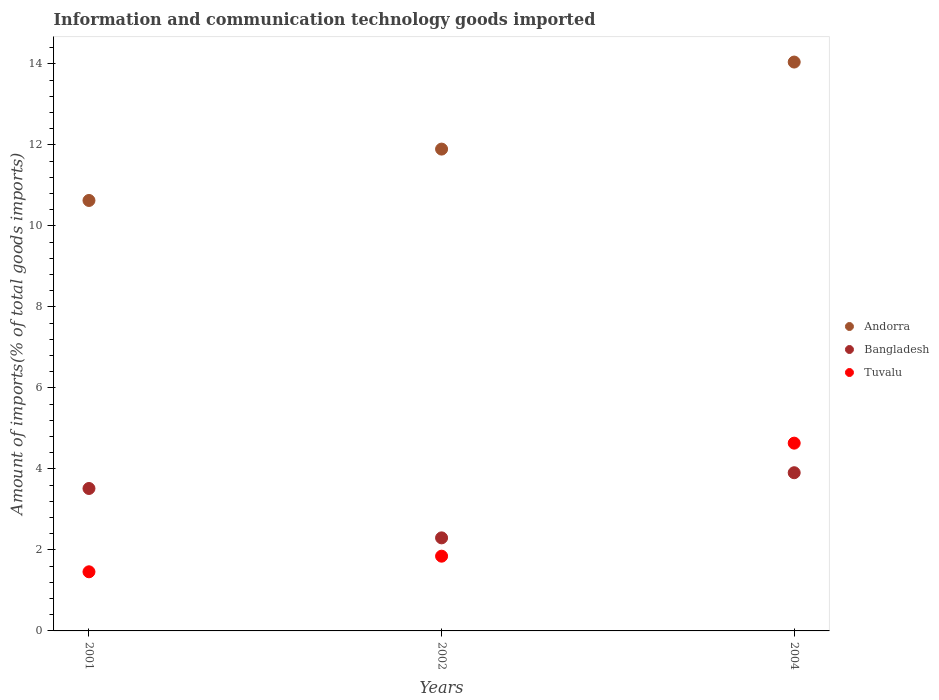How many different coloured dotlines are there?
Give a very brief answer. 3. What is the amount of goods imported in Tuvalu in 2004?
Offer a very short reply. 4.64. Across all years, what is the maximum amount of goods imported in Andorra?
Keep it short and to the point. 14.05. Across all years, what is the minimum amount of goods imported in Bangladesh?
Keep it short and to the point. 2.3. What is the total amount of goods imported in Tuvalu in the graph?
Provide a succinct answer. 7.94. What is the difference between the amount of goods imported in Tuvalu in 2002 and that in 2004?
Your answer should be compact. -2.79. What is the difference between the amount of goods imported in Tuvalu in 2004 and the amount of goods imported in Andorra in 2002?
Give a very brief answer. -7.26. What is the average amount of goods imported in Tuvalu per year?
Provide a short and direct response. 2.65. In the year 2001, what is the difference between the amount of goods imported in Tuvalu and amount of goods imported in Andorra?
Keep it short and to the point. -9.17. In how many years, is the amount of goods imported in Tuvalu greater than 8.4 %?
Give a very brief answer. 0. What is the ratio of the amount of goods imported in Bangladesh in 2001 to that in 2002?
Provide a succinct answer. 1.53. Is the amount of goods imported in Tuvalu in 2001 less than that in 2002?
Offer a terse response. Yes. Is the difference between the amount of goods imported in Tuvalu in 2001 and 2002 greater than the difference between the amount of goods imported in Andorra in 2001 and 2002?
Offer a terse response. Yes. What is the difference between the highest and the second highest amount of goods imported in Andorra?
Offer a terse response. 2.15. What is the difference between the highest and the lowest amount of goods imported in Bangladesh?
Ensure brevity in your answer.  1.61. Is the sum of the amount of goods imported in Tuvalu in 2001 and 2004 greater than the maximum amount of goods imported in Bangladesh across all years?
Keep it short and to the point. Yes. Is it the case that in every year, the sum of the amount of goods imported in Andorra and amount of goods imported in Tuvalu  is greater than the amount of goods imported in Bangladesh?
Your answer should be very brief. Yes. How many dotlines are there?
Keep it short and to the point. 3. How many years are there in the graph?
Make the answer very short. 3. Are the values on the major ticks of Y-axis written in scientific E-notation?
Provide a succinct answer. No. Does the graph contain grids?
Your response must be concise. No. What is the title of the graph?
Ensure brevity in your answer.  Information and communication technology goods imported. Does "World" appear as one of the legend labels in the graph?
Your response must be concise. No. What is the label or title of the Y-axis?
Offer a very short reply. Amount of imports(% of total goods imports). What is the Amount of imports(% of total goods imports) of Andorra in 2001?
Ensure brevity in your answer.  10.63. What is the Amount of imports(% of total goods imports) of Bangladesh in 2001?
Your answer should be compact. 3.52. What is the Amount of imports(% of total goods imports) in Tuvalu in 2001?
Your answer should be compact. 1.46. What is the Amount of imports(% of total goods imports) in Andorra in 2002?
Offer a very short reply. 11.9. What is the Amount of imports(% of total goods imports) in Bangladesh in 2002?
Offer a very short reply. 2.3. What is the Amount of imports(% of total goods imports) in Tuvalu in 2002?
Your response must be concise. 1.85. What is the Amount of imports(% of total goods imports) of Andorra in 2004?
Your response must be concise. 14.05. What is the Amount of imports(% of total goods imports) in Bangladesh in 2004?
Keep it short and to the point. 3.91. What is the Amount of imports(% of total goods imports) of Tuvalu in 2004?
Make the answer very short. 4.64. Across all years, what is the maximum Amount of imports(% of total goods imports) of Andorra?
Keep it short and to the point. 14.05. Across all years, what is the maximum Amount of imports(% of total goods imports) of Bangladesh?
Your answer should be very brief. 3.91. Across all years, what is the maximum Amount of imports(% of total goods imports) in Tuvalu?
Give a very brief answer. 4.64. Across all years, what is the minimum Amount of imports(% of total goods imports) in Andorra?
Offer a very short reply. 10.63. Across all years, what is the minimum Amount of imports(% of total goods imports) in Bangladesh?
Make the answer very short. 2.3. Across all years, what is the minimum Amount of imports(% of total goods imports) in Tuvalu?
Ensure brevity in your answer.  1.46. What is the total Amount of imports(% of total goods imports) of Andorra in the graph?
Give a very brief answer. 36.57. What is the total Amount of imports(% of total goods imports) in Bangladesh in the graph?
Provide a short and direct response. 9.72. What is the total Amount of imports(% of total goods imports) in Tuvalu in the graph?
Provide a succinct answer. 7.94. What is the difference between the Amount of imports(% of total goods imports) of Andorra in 2001 and that in 2002?
Provide a short and direct response. -1.27. What is the difference between the Amount of imports(% of total goods imports) of Bangladesh in 2001 and that in 2002?
Provide a short and direct response. 1.22. What is the difference between the Amount of imports(% of total goods imports) in Tuvalu in 2001 and that in 2002?
Ensure brevity in your answer.  -0.39. What is the difference between the Amount of imports(% of total goods imports) of Andorra in 2001 and that in 2004?
Provide a succinct answer. -3.42. What is the difference between the Amount of imports(% of total goods imports) of Bangladesh in 2001 and that in 2004?
Offer a terse response. -0.39. What is the difference between the Amount of imports(% of total goods imports) of Tuvalu in 2001 and that in 2004?
Offer a terse response. -3.18. What is the difference between the Amount of imports(% of total goods imports) of Andorra in 2002 and that in 2004?
Ensure brevity in your answer.  -2.15. What is the difference between the Amount of imports(% of total goods imports) in Bangladesh in 2002 and that in 2004?
Provide a short and direct response. -1.61. What is the difference between the Amount of imports(% of total goods imports) in Tuvalu in 2002 and that in 2004?
Offer a very short reply. -2.79. What is the difference between the Amount of imports(% of total goods imports) of Andorra in 2001 and the Amount of imports(% of total goods imports) of Bangladesh in 2002?
Provide a short and direct response. 8.33. What is the difference between the Amount of imports(% of total goods imports) in Andorra in 2001 and the Amount of imports(% of total goods imports) in Tuvalu in 2002?
Make the answer very short. 8.78. What is the difference between the Amount of imports(% of total goods imports) in Bangladesh in 2001 and the Amount of imports(% of total goods imports) in Tuvalu in 2002?
Your answer should be very brief. 1.67. What is the difference between the Amount of imports(% of total goods imports) of Andorra in 2001 and the Amount of imports(% of total goods imports) of Bangladesh in 2004?
Provide a succinct answer. 6.72. What is the difference between the Amount of imports(% of total goods imports) in Andorra in 2001 and the Amount of imports(% of total goods imports) in Tuvalu in 2004?
Your answer should be compact. 5.99. What is the difference between the Amount of imports(% of total goods imports) of Bangladesh in 2001 and the Amount of imports(% of total goods imports) of Tuvalu in 2004?
Your response must be concise. -1.12. What is the difference between the Amount of imports(% of total goods imports) of Andorra in 2002 and the Amount of imports(% of total goods imports) of Bangladesh in 2004?
Your answer should be compact. 7.99. What is the difference between the Amount of imports(% of total goods imports) in Andorra in 2002 and the Amount of imports(% of total goods imports) in Tuvalu in 2004?
Keep it short and to the point. 7.26. What is the difference between the Amount of imports(% of total goods imports) of Bangladesh in 2002 and the Amount of imports(% of total goods imports) of Tuvalu in 2004?
Give a very brief answer. -2.34. What is the average Amount of imports(% of total goods imports) of Andorra per year?
Make the answer very short. 12.19. What is the average Amount of imports(% of total goods imports) of Bangladesh per year?
Your answer should be compact. 3.24. What is the average Amount of imports(% of total goods imports) in Tuvalu per year?
Provide a short and direct response. 2.65. In the year 2001, what is the difference between the Amount of imports(% of total goods imports) in Andorra and Amount of imports(% of total goods imports) in Bangladesh?
Offer a terse response. 7.11. In the year 2001, what is the difference between the Amount of imports(% of total goods imports) in Andorra and Amount of imports(% of total goods imports) in Tuvalu?
Provide a short and direct response. 9.17. In the year 2001, what is the difference between the Amount of imports(% of total goods imports) in Bangladesh and Amount of imports(% of total goods imports) in Tuvalu?
Offer a very short reply. 2.06. In the year 2002, what is the difference between the Amount of imports(% of total goods imports) of Andorra and Amount of imports(% of total goods imports) of Bangladesh?
Offer a terse response. 9.6. In the year 2002, what is the difference between the Amount of imports(% of total goods imports) in Andorra and Amount of imports(% of total goods imports) in Tuvalu?
Provide a short and direct response. 10.05. In the year 2002, what is the difference between the Amount of imports(% of total goods imports) in Bangladesh and Amount of imports(% of total goods imports) in Tuvalu?
Make the answer very short. 0.45. In the year 2004, what is the difference between the Amount of imports(% of total goods imports) of Andorra and Amount of imports(% of total goods imports) of Bangladesh?
Provide a short and direct response. 10.14. In the year 2004, what is the difference between the Amount of imports(% of total goods imports) in Andorra and Amount of imports(% of total goods imports) in Tuvalu?
Ensure brevity in your answer.  9.41. In the year 2004, what is the difference between the Amount of imports(% of total goods imports) in Bangladesh and Amount of imports(% of total goods imports) in Tuvalu?
Provide a short and direct response. -0.73. What is the ratio of the Amount of imports(% of total goods imports) of Andorra in 2001 to that in 2002?
Give a very brief answer. 0.89. What is the ratio of the Amount of imports(% of total goods imports) in Bangladesh in 2001 to that in 2002?
Offer a terse response. 1.53. What is the ratio of the Amount of imports(% of total goods imports) in Tuvalu in 2001 to that in 2002?
Your response must be concise. 0.79. What is the ratio of the Amount of imports(% of total goods imports) in Andorra in 2001 to that in 2004?
Ensure brevity in your answer.  0.76. What is the ratio of the Amount of imports(% of total goods imports) of Bangladesh in 2001 to that in 2004?
Your answer should be compact. 0.9. What is the ratio of the Amount of imports(% of total goods imports) in Tuvalu in 2001 to that in 2004?
Your response must be concise. 0.31. What is the ratio of the Amount of imports(% of total goods imports) of Andorra in 2002 to that in 2004?
Offer a very short reply. 0.85. What is the ratio of the Amount of imports(% of total goods imports) in Bangladesh in 2002 to that in 2004?
Offer a terse response. 0.59. What is the ratio of the Amount of imports(% of total goods imports) in Tuvalu in 2002 to that in 2004?
Offer a terse response. 0.4. What is the difference between the highest and the second highest Amount of imports(% of total goods imports) of Andorra?
Provide a short and direct response. 2.15. What is the difference between the highest and the second highest Amount of imports(% of total goods imports) of Bangladesh?
Offer a very short reply. 0.39. What is the difference between the highest and the second highest Amount of imports(% of total goods imports) of Tuvalu?
Ensure brevity in your answer.  2.79. What is the difference between the highest and the lowest Amount of imports(% of total goods imports) of Andorra?
Make the answer very short. 3.42. What is the difference between the highest and the lowest Amount of imports(% of total goods imports) of Bangladesh?
Offer a terse response. 1.61. What is the difference between the highest and the lowest Amount of imports(% of total goods imports) in Tuvalu?
Keep it short and to the point. 3.18. 